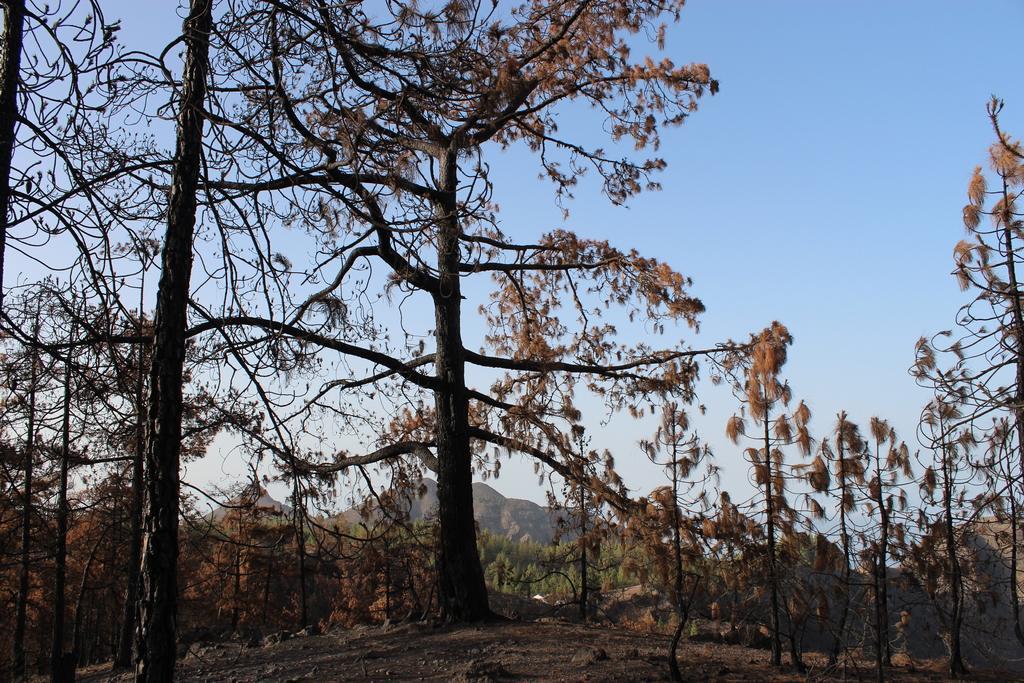Describe this image in one or two sentences. In the picture there are plenty of trees around the ground and in the background there is a mountain. 